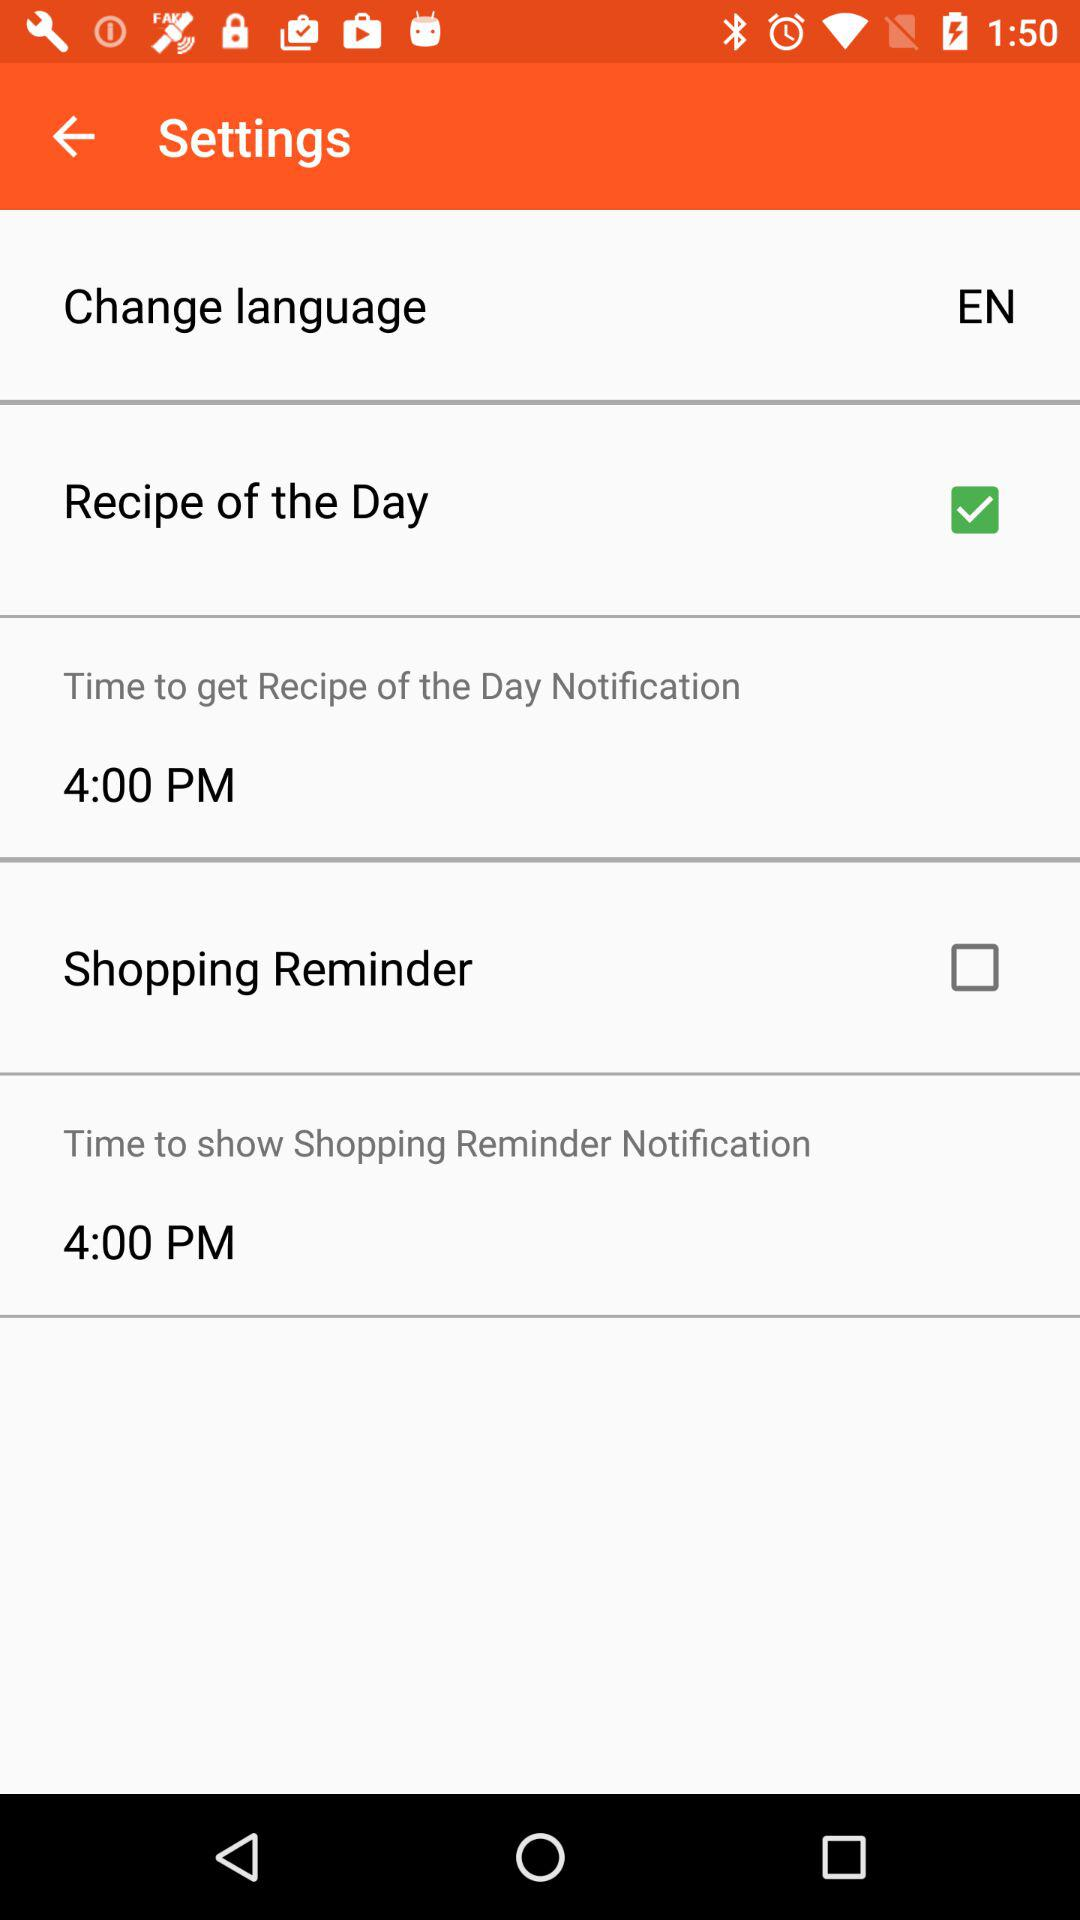What's the status for "Shopping Reminder"? The status is "off". 